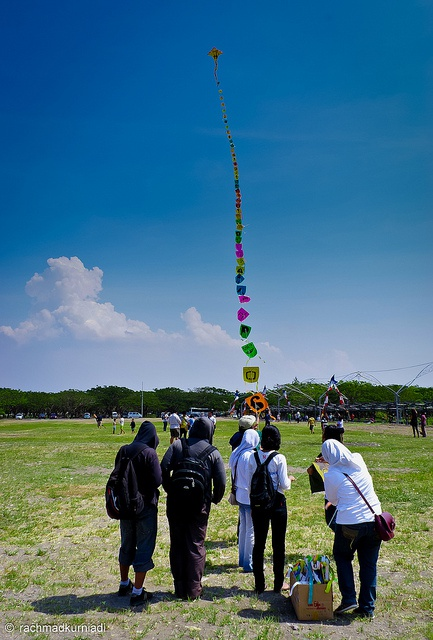Describe the objects in this image and their specific colors. I can see people in darkblue, black, gray, navy, and darkgray tones, people in darkblue, black, white, and darkgray tones, people in darkblue, black, navy, gray, and olive tones, people in darkblue, black, gray, and lavender tones, and people in darkblue, black, olive, and gray tones in this image. 